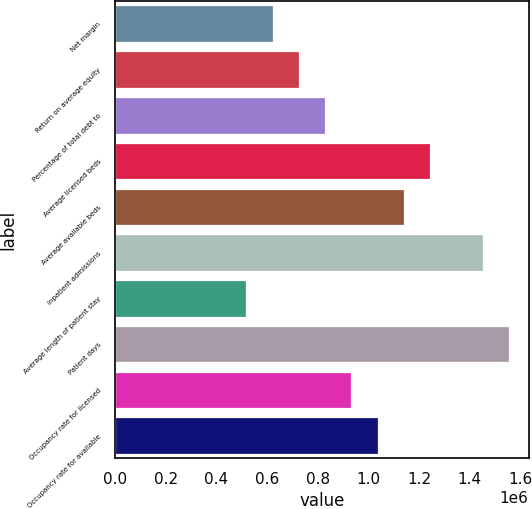Convert chart to OTSL. <chart><loc_0><loc_0><loc_500><loc_500><bar_chart><fcel>Net margin<fcel>Return on average equity<fcel>Percentage of total debt to<fcel>Average licensed beds<fcel>Average available beds<fcel>Inpatient admissions<fcel>Average length of patient stay<fcel>Patient days<fcel>Occupancy rate for licensed<fcel>Occupancy rate for available<nl><fcel>621820<fcel>725456<fcel>829093<fcel>1.24364e+06<fcel>1.14e+06<fcel>1.45091e+06<fcel>518183<fcel>1.55455e+06<fcel>932729<fcel>1.03637e+06<nl></chart> 